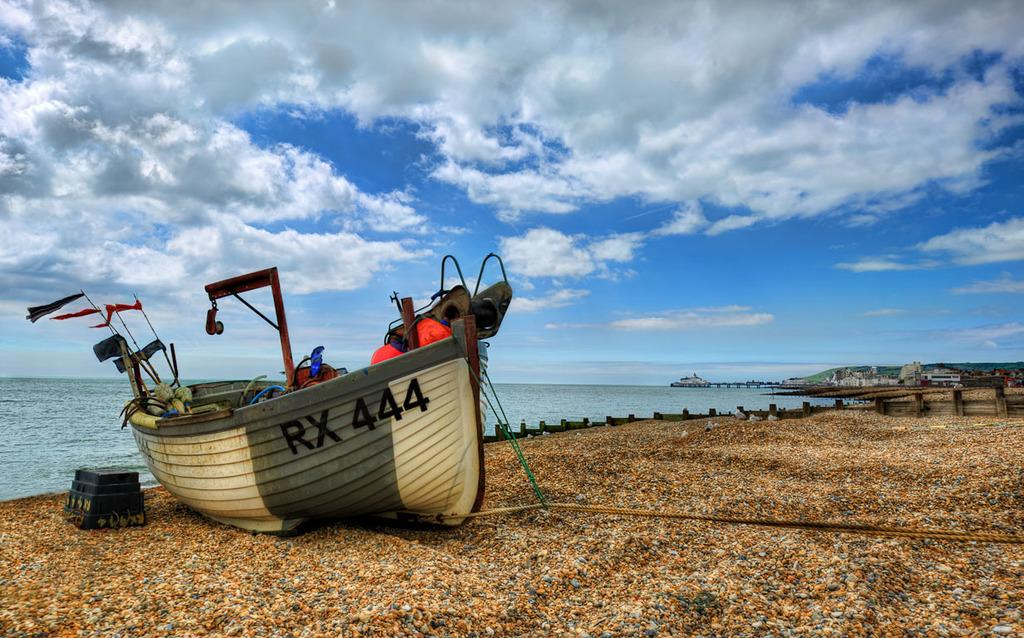<image>
Offer a succinct explanation of the picture presented. the word rx and 444 on a boat that is on the ground 